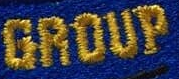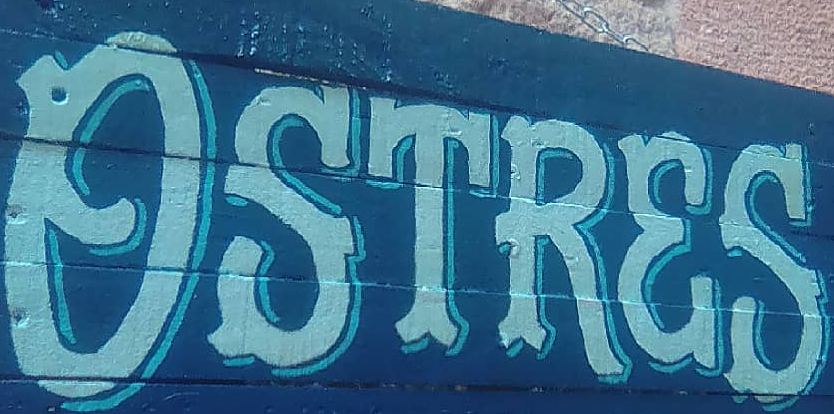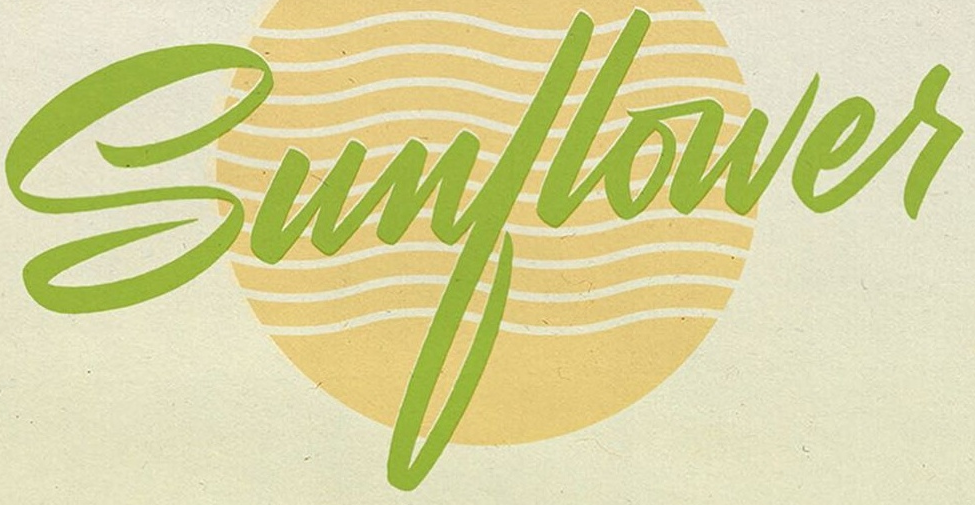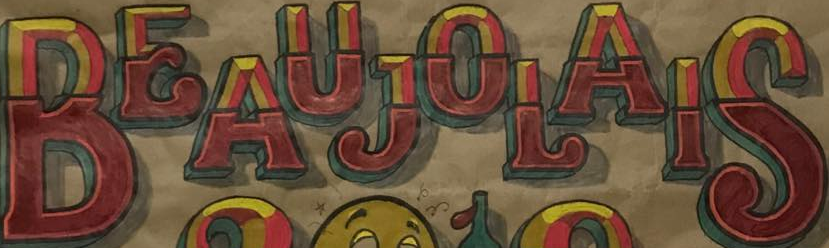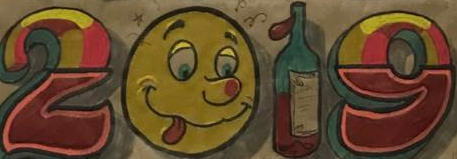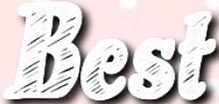Read the text content from these images in order, separated by a semicolon. GROUP; OSTRES; Sunflowes; BEAUJOLAIS; 2019; Best 